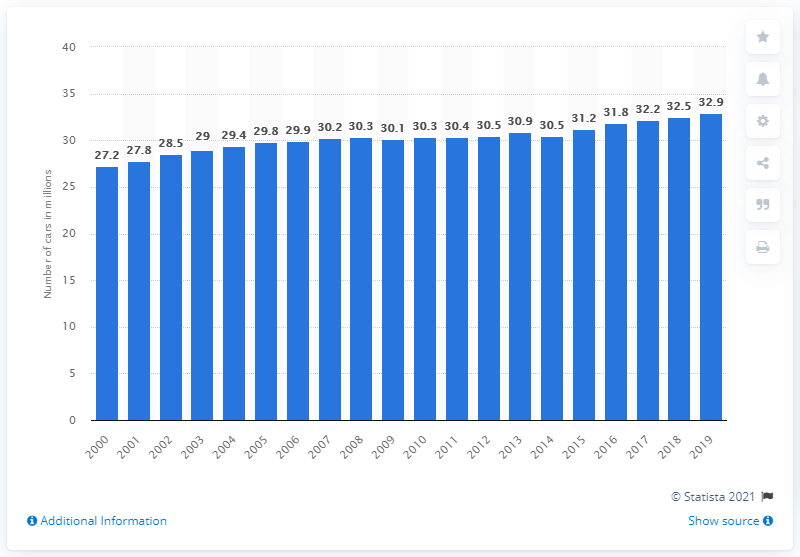Indicate a few pertinent items in this graphic. In 2019, there were approximately 32.9 million passenger cars in the United Kingdom. 